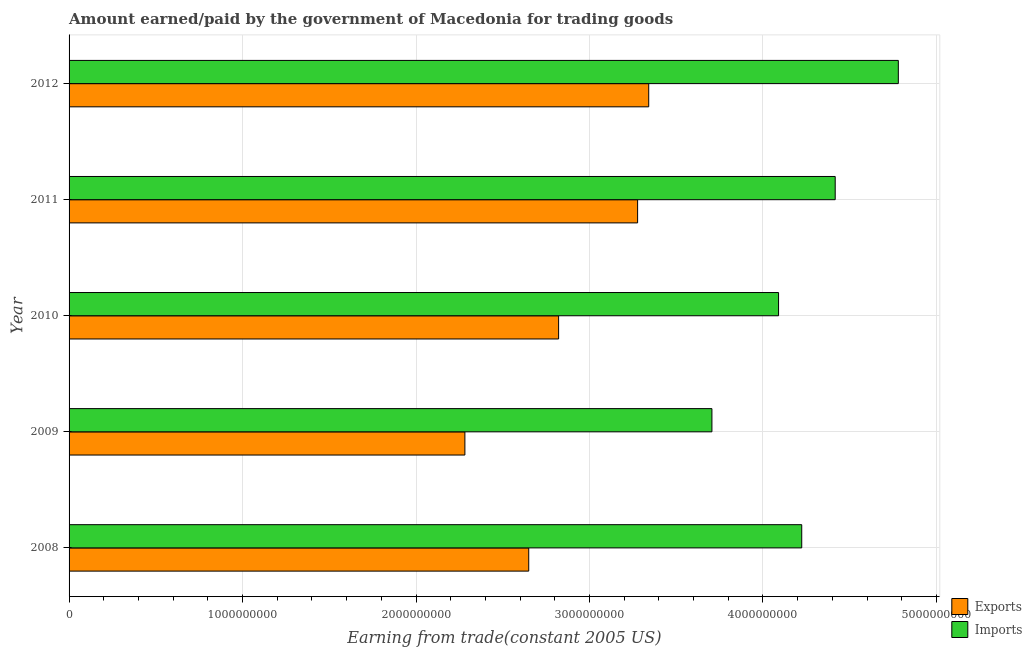How many different coloured bars are there?
Give a very brief answer. 2. How many groups of bars are there?
Offer a very short reply. 5. How many bars are there on the 1st tick from the top?
Your answer should be very brief. 2. What is the amount earned from exports in 2008?
Make the answer very short. 2.65e+09. Across all years, what is the maximum amount earned from exports?
Provide a short and direct response. 3.34e+09. Across all years, what is the minimum amount earned from exports?
Offer a terse response. 2.28e+09. In which year was the amount paid for imports maximum?
Offer a terse response. 2012. In which year was the amount paid for imports minimum?
Give a very brief answer. 2009. What is the total amount earned from exports in the graph?
Provide a succinct answer. 1.44e+1. What is the difference between the amount paid for imports in 2010 and that in 2011?
Make the answer very short. -3.27e+08. What is the difference between the amount paid for imports in 2008 and the amount earned from exports in 2012?
Provide a succinct answer. 8.82e+08. What is the average amount paid for imports per year?
Your response must be concise. 4.24e+09. In the year 2008, what is the difference between the amount paid for imports and amount earned from exports?
Provide a succinct answer. 1.57e+09. What is the ratio of the amount earned from exports in 2010 to that in 2011?
Provide a succinct answer. 0.86. Is the amount paid for imports in 2009 less than that in 2012?
Give a very brief answer. Yes. Is the difference between the amount paid for imports in 2008 and 2009 greater than the difference between the amount earned from exports in 2008 and 2009?
Your response must be concise. Yes. What is the difference between the highest and the second highest amount earned from exports?
Make the answer very short. 6.40e+07. What is the difference between the highest and the lowest amount paid for imports?
Offer a terse response. 1.07e+09. In how many years, is the amount paid for imports greater than the average amount paid for imports taken over all years?
Ensure brevity in your answer.  2. What does the 1st bar from the top in 2011 represents?
Ensure brevity in your answer.  Imports. What does the 2nd bar from the bottom in 2012 represents?
Offer a terse response. Imports. Are all the bars in the graph horizontal?
Provide a succinct answer. Yes. How many years are there in the graph?
Your response must be concise. 5. What is the difference between two consecutive major ticks on the X-axis?
Your response must be concise. 1.00e+09. Are the values on the major ticks of X-axis written in scientific E-notation?
Offer a very short reply. No. Does the graph contain any zero values?
Ensure brevity in your answer.  No. Does the graph contain grids?
Make the answer very short. Yes. Where does the legend appear in the graph?
Offer a very short reply. Bottom right. How many legend labels are there?
Your response must be concise. 2. How are the legend labels stacked?
Provide a succinct answer. Vertical. What is the title of the graph?
Make the answer very short. Amount earned/paid by the government of Macedonia for trading goods. What is the label or title of the X-axis?
Offer a terse response. Earning from trade(constant 2005 US). What is the Earning from trade(constant 2005 US) of Exports in 2008?
Offer a terse response. 2.65e+09. What is the Earning from trade(constant 2005 US) of Imports in 2008?
Make the answer very short. 4.22e+09. What is the Earning from trade(constant 2005 US) of Exports in 2009?
Give a very brief answer. 2.28e+09. What is the Earning from trade(constant 2005 US) of Imports in 2009?
Your answer should be compact. 3.71e+09. What is the Earning from trade(constant 2005 US) of Exports in 2010?
Your answer should be very brief. 2.82e+09. What is the Earning from trade(constant 2005 US) of Imports in 2010?
Provide a succinct answer. 4.09e+09. What is the Earning from trade(constant 2005 US) in Exports in 2011?
Your answer should be very brief. 3.28e+09. What is the Earning from trade(constant 2005 US) of Imports in 2011?
Give a very brief answer. 4.42e+09. What is the Earning from trade(constant 2005 US) in Exports in 2012?
Give a very brief answer. 3.34e+09. What is the Earning from trade(constant 2005 US) in Imports in 2012?
Your answer should be very brief. 4.78e+09. Across all years, what is the maximum Earning from trade(constant 2005 US) of Exports?
Your answer should be compact. 3.34e+09. Across all years, what is the maximum Earning from trade(constant 2005 US) of Imports?
Your answer should be compact. 4.78e+09. Across all years, what is the minimum Earning from trade(constant 2005 US) of Exports?
Ensure brevity in your answer.  2.28e+09. Across all years, what is the minimum Earning from trade(constant 2005 US) of Imports?
Your answer should be compact. 3.71e+09. What is the total Earning from trade(constant 2005 US) in Exports in the graph?
Your answer should be very brief. 1.44e+1. What is the total Earning from trade(constant 2005 US) in Imports in the graph?
Give a very brief answer. 2.12e+1. What is the difference between the Earning from trade(constant 2005 US) of Exports in 2008 and that in 2009?
Offer a very short reply. 3.68e+08. What is the difference between the Earning from trade(constant 2005 US) in Imports in 2008 and that in 2009?
Your answer should be very brief. 5.18e+08. What is the difference between the Earning from trade(constant 2005 US) of Exports in 2008 and that in 2010?
Keep it short and to the point. -1.72e+08. What is the difference between the Earning from trade(constant 2005 US) in Imports in 2008 and that in 2010?
Provide a succinct answer. 1.34e+08. What is the difference between the Earning from trade(constant 2005 US) in Exports in 2008 and that in 2011?
Offer a very short reply. -6.28e+08. What is the difference between the Earning from trade(constant 2005 US) in Imports in 2008 and that in 2011?
Ensure brevity in your answer.  -1.93e+08. What is the difference between the Earning from trade(constant 2005 US) in Exports in 2008 and that in 2012?
Provide a succinct answer. -6.92e+08. What is the difference between the Earning from trade(constant 2005 US) of Imports in 2008 and that in 2012?
Provide a short and direct response. -5.57e+08. What is the difference between the Earning from trade(constant 2005 US) of Exports in 2009 and that in 2010?
Your answer should be compact. -5.40e+08. What is the difference between the Earning from trade(constant 2005 US) in Imports in 2009 and that in 2010?
Provide a short and direct response. -3.84e+08. What is the difference between the Earning from trade(constant 2005 US) of Exports in 2009 and that in 2011?
Provide a short and direct response. -9.96e+08. What is the difference between the Earning from trade(constant 2005 US) of Imports in 2009 and that in 2011?
Provide a short and direct response. -7.11e+08. What is the difference between the Earning from trade(constant 2005 US) in Exports in 2009 and that in 2012?
Provide a succinct answer. -1.06e+09. What is the difference between the Earning from trade(constant 2005 US) in Imports in 2009 and that in 2012?
Your response must be concise. -1.07e+09. What is the difference between the Earning from trade(constant 2005 US) in Exports in 2010 and that in 2011?
Your response must be concise. -4.55e+08. What is the difference between the Earning from trade(constant 2005 US) in Imports in 2010 and that in 2011?
Keep it short and to the point. -3.27e+08. What is the difference between the Earning from trade(constant 2005 US) of Exports in 2010 and that in 2012?
Provide a succinct answer. -5.19e+08. What is the difference between the Earning from trade(constant 2005 US) of Imports in 2010 and that in 2012?
Offer a very short reply. -6.90e+08. What is the difference between the Earning from trade(constant 2005 US) in Exports in 2011 and that in 2012?
Ensure brevity in your answer.  -6.40e+07. What is the difference between the Earning from trade(constant 2005 US) in Imports in 2011 and that in 2012?
Your response must be concise. -3.64e+08. What is the difference between the Earning from trade(constant 2005 US) of Exports in 2008 and the Earning from trade(constant 2005 US) of Imports in 2009?
Make the answer very short. -1.06e+09. What is the difference between the Earning from trade(constant 2005 US) of Exports in 2008 and the Earning from trade(constant 2005 US) of Imports in 2010?
Ensure brevity in your answer.  -1.44e+09. What is the difference between the Earning from trade(constant 2005 US) in Exports in 2008 and the Earning from trade(constant 2005 US) in Imports in 2011?
Provide a short and direct response. -1.77e+09. What is the difference between the Earning from trade(constant 2005 US) of Exports in 2008 and the Earning from trade(constant 2005 US) of Imports in 2012?
Provide a succinct answer. -2.13e+09. What is the difference between the Earning from trade(constant 2005 US) in Exports in 2009 and the Earning from trade(constant 2005 US) in Imports in 2010?
Give a very brief answer. -1.81e+09. What is the difference between the Earning from trade(constant 2005 US) of Exports in 2009 and the Earning from trade(constant 2005 US) of Imports in 2011?
Make the answer very short. -2.13e+09. What is the difference between the Earning from trade(constant 2005 US) of Exports in 2009 and the Earning from trade(constant 2005 US) of Imports in 2012?
Provide a short and direct response. -2.50e+09. What is the difference between the Earning from trade(constant 2005 US) in Exports in 2010 and the Earning from trade(constant 2005 US) in Imports in 2011?
Make the answer very short. -1.59e+09. What is the difference between the Earning from trade(constant 2005 US) in Exports in 2010 and the Earning from trade(constant 2005 US) in Imports in 2012?
Offer a very short reply. -1.96e+09. What is the difference between the Earning from trade(constant 2005 US) of Exports in 2011 and the Earning from trade(constant 2005 US) of Imports in 2012?
Provide a succinct answer. -1.50e+09. What is the average Earning from trade(constant 2005 US) in Exports per year?
Your answer should be compact. 2.87e+09. What is the average Earning from trade(constant 2005 US) of Imports per year?
Your answer should be very brief. 4.24e+09. In the year 2008, what is the difference between the Earning from trade(constant 2005 US) in Exports and Earning from trade(constant 2005 US) in Imports?
Ensure brevity in your answer.  -1.57e+09. In the year 2009, what is the difference between the Earning from trade(constant 2005 US) in Exports and Earning from trade(constant 2005 US) in Imports?
Provide a short and direct response. -1.42e+09. In the year 2010, what is the difference between the Earning from trade(constant 2005 US) in Exports and Earning from trade(constant 2005 US) in Imports?
Your answer should be compact. -1.27e+09. In the year 2011, what is the difference between the Earning from trade(constant 2005 US) of Exports and Earning from trade(constant 2005 US) of Imports?
Offer a terse response. -1.14e+09. In the year 2012, what is the difference between the Earning from trade(constant 2005 US) of Exports and Earning from trade(constant 2005 US) of Imports?
Keep it short and to the point. -1.44e+09. What is the ratio of the Earning from trade(constant 2005 US) of Exports in 2008 to that in 2009?
Provide a short and direct response. 1.16. What is the ratio of the Earning from trade(constant 2005 US) of Imports in 2008 to that in 2009?
Ensure brevity in your answer.  1.14. What is the ratio of the Earning from trade(constant 2005 US) of Exports in 2008 to that in 2010?
Your answer should be very brief. 0.94. What is the ratio of the Earning from trade(constant 2005 US) of Imports in 2008 to that in 2010?
Ensure brevity in your answer.  1.03. What is the ratio of the Earning from trade(constant 2005 US) in Exports in 2008 to that in 2011?
Your response must be concise. 0.81. What is the ratio of the Earning from trade(constant 2005 US) of Imports in 2008 to that in 2011?
Keep it short and to the point. 0.96. What is the ratio of the Earning from trade(constant 2005 US) in Exports in 2008 to that in 2012?
Keep it short and to the point. 0.79. What is the ratio of the Earning from trade(constant 2005 US) in Imports in 2008 to that in 2012?
Your answer should be very brief. 0.88. What is the ratio of the Earning from trade(constant 2005 US) of Exports in 2009 to that in 2010?
Give a very brief answer. 0.81. What is the ratio of the Earning from trade(constant 2005 US) of Imports in 2009 to that in 2010?
Provide a short and direct response. 0.91. What is the ratio of the Earning from trade(constant 2005 US) in Exports in 2009 to that in 2011?
Provide a short and direct response. 0.7. What is the ratio of the Earning from trade(constant 2005 US) of Imports in 2009 to that in 2011?
Your answer should be very brief. 0.84. What is the ratio of the Earning from trade(constant 2005 US) in Exports in 2009 to that in 2012?
Your response must be concise. 0.68. What is the ratio of the Earning from trade(constant 2005 US) of Imports in 2009 to that in 2012?
Provide a succinct answer. 0.78. What is the ratio of the Earning from trade(constant 2005 US) in Exports in 2010 to that in 2011?
Make the answer very short. 0.86. What is the ratio of the Earning from trade(constant 2005 US) in Imports in 2010 to that in 2011?
Provide a succinct answer. 0.93. What is the ratio of the Earning from trade(constant 2005 US) of Exports in 2010 to that in 2012?
Offer a terse response. 0.84. What is the ratio of the Earning from trade(constant 2005 US) of Imports in 2010 to that in 2012?
Your answer should be very brief. 0.86. What is the ratio of the Earning from trade(constant 2005 US) in Exports in 2011 to that in 2012?
Your response must be concise. 0.98. What is the ratio of the Earning from trade(constant 2005 US) in Imports in 2011 to that in 2012?
Offer a very short reply. 0.92. What is the difference between the highest and the second highest Earning from trade(constant 2005 US) in Exports?
Make the answer very short. 6.40e+07. What is the difference between the highest and the second highest Earning from trade(constant 2005 US) of Imports?
Your answer should be very brief. 3.64e+08. What is the difference between the highest and the lowest Earning from trade(constant 2005 US) of Exports?
Ensure brevity in your answer.  1.06e+09. What is the difference between the highest and the lowest Earning from trade(constant 2005 US) of Imports?
Ensure brevity in your answer.  1.07e+09. 